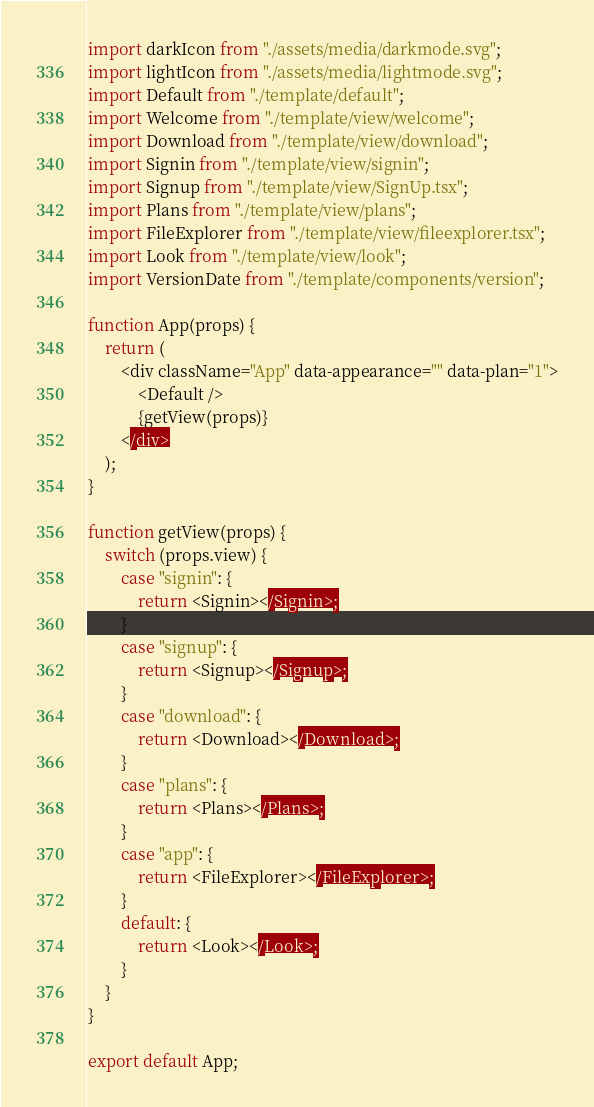Convert code to text. <code><loc_0><loc_0><loc_500><loc_500><_JavaScript_>import darkIcon from "./assets/media/darkmode.svg";
import lightIcon from "./assets/media/lightmode.svg";
import Default from "./template/default";
import Welcome from "./template/view/welcome";
import Download from "./template/view/download";
import Signin from "./template/view/signin";
import Signup from "./template/view/SignUp.tsx";
import Plans from "./template/view/plans";
import FileExplorer from "./template/view/fileexplorer.tsx";
import Look from "./template/view/look";
import VersionDate from "./template/components/version";

function App(props) {
	return (
		<div className="App" data-appearance="" data-plan="1">
			<Default />
			{getView(props)}
		</div>
	);
}

function getView(props) {
	switch (props.view) {
		case "signin": {
			return <Signin></Signin>;
		}
		case "signup": {
			return <Signup></Signup>;
		}
		case "download": {
			return <Download></Download>;
		}
		case "plans": {
			return <Plans></Plans>;
		}
		case "app": {
			return <FileExplorer></FileExplorer>;
		}
		default: {
			return <Look></Look>;
		}
	}
}

export default App;
</code> 